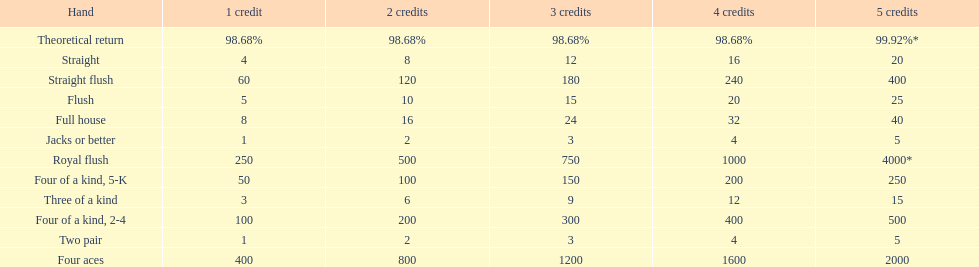Give me the full table as a dictionary. {'header': ['Hand', '1 credit', '2 credits', '3 credits', '4 credits', '5 credits'], 'rows': [['Theoretical return', '98.68%', '98.68%', '98.68%', '98.68%', '99.92%*'], ['Straight', '4', '8', '12', '16', '20'], ['Straight flush', '60', '120', '180', '240', '400'], ['Flush', '5', '10', '15', '20', '25'], ['Full house', '8', '16', '24', '32', '40'], ['Jacks or better', '1', '2', '3', '4', '5'], ['Royal flush', '250', '500', '750', '1000', '4000*'], ['Four of a kind, 5-K', '50', '100', '150', '200', '250'], ['Three of a kind', '3', '6', '9', '12', '15'], ['Four of a kind, 2-4', '100', '200', '300', '400', '500'], ['Two pair', '1', '2', '3', '4', '5'], ['Four aces', '400', '800', '1200', '1600', '2000']]} Which hand is the top hand in the card game super aces? Royal flush. 